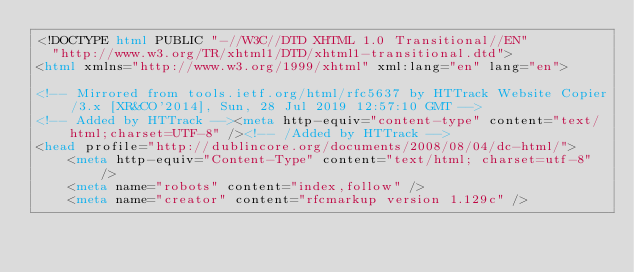Convert code to text. <code><loc_0><loc_0><loc_500><loc_500><_HTML_><!DOCTYPE html PUBLIC "-//W3C//DTD XHTML 1.0 Transitional//EN"
  "http://www.w3.org/TR/xhtml1/DTD/xhtml1-transitional.dtd">
<html xmlns="http://www.w3.org/1999/xhtml" xml:lang="en" lang="en">

<!-- Mirrored from tools.ietf.org/html/rfc5637 by HTTrack Website Copier/3.x [XR&CO'2014], Sun, 28 Jul 2019 12:57:10 GMT -->
<!-- Added by HTTrack --><meta http-equiv="content-type" content="text/html;charset=UTF-8" /><!-- /Added by HTTrack -->
<head profile="http://dublincore.org/documents/2008/08/04/dc-html/">
    <meta http-equiv="Content-Type" content="text/html; charset=utf-8" />
    <meta name="robots" content="index,follow" />
    <meta name="creator" content="rfcmarkup version 1.129c" /></code> 